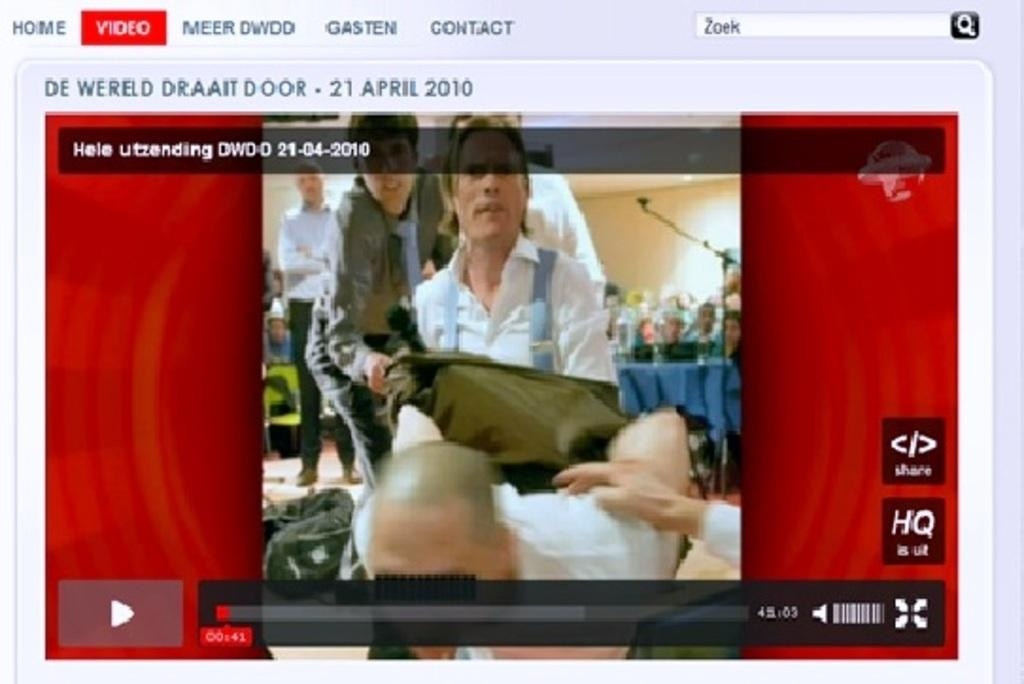<image>
Describe the image concisely. A computer screen showing a video called De Wereld Draait Door. 